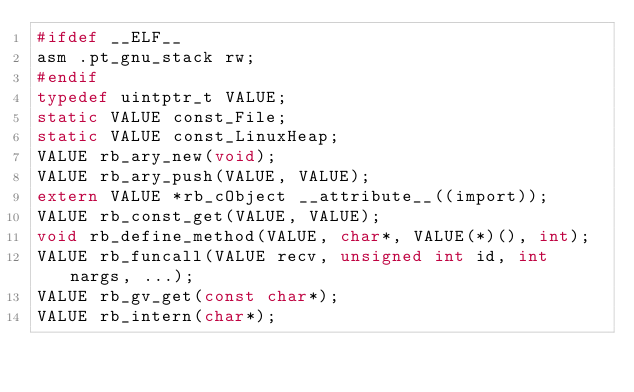<code> <loc_0><loc_0><loc_500><loc_500><_C_>#ifdef __ELF__
asm .pt_gnu_stack rw;
#endif
typedef uintptr_t VALUE;
static VALUE const_File;
static VALUE const_LinuxHeap;
VALUE rb_ary_new(void);
VALUE rb_ary_push(VALUE, VALUE);
extern VALUE *rb_cObject __attribute__((import));
VALUE rb_const_get(VALUE, VALUE);
void rb_define_method(VALUE, char*, VALUE(*)(), int);
VALUE rb_funcall(VALUE recv, unsigned int id, int nargs, ...);
VALUE rb_gv_get(const char*);
VALUE rb_intern(char*);</code> 